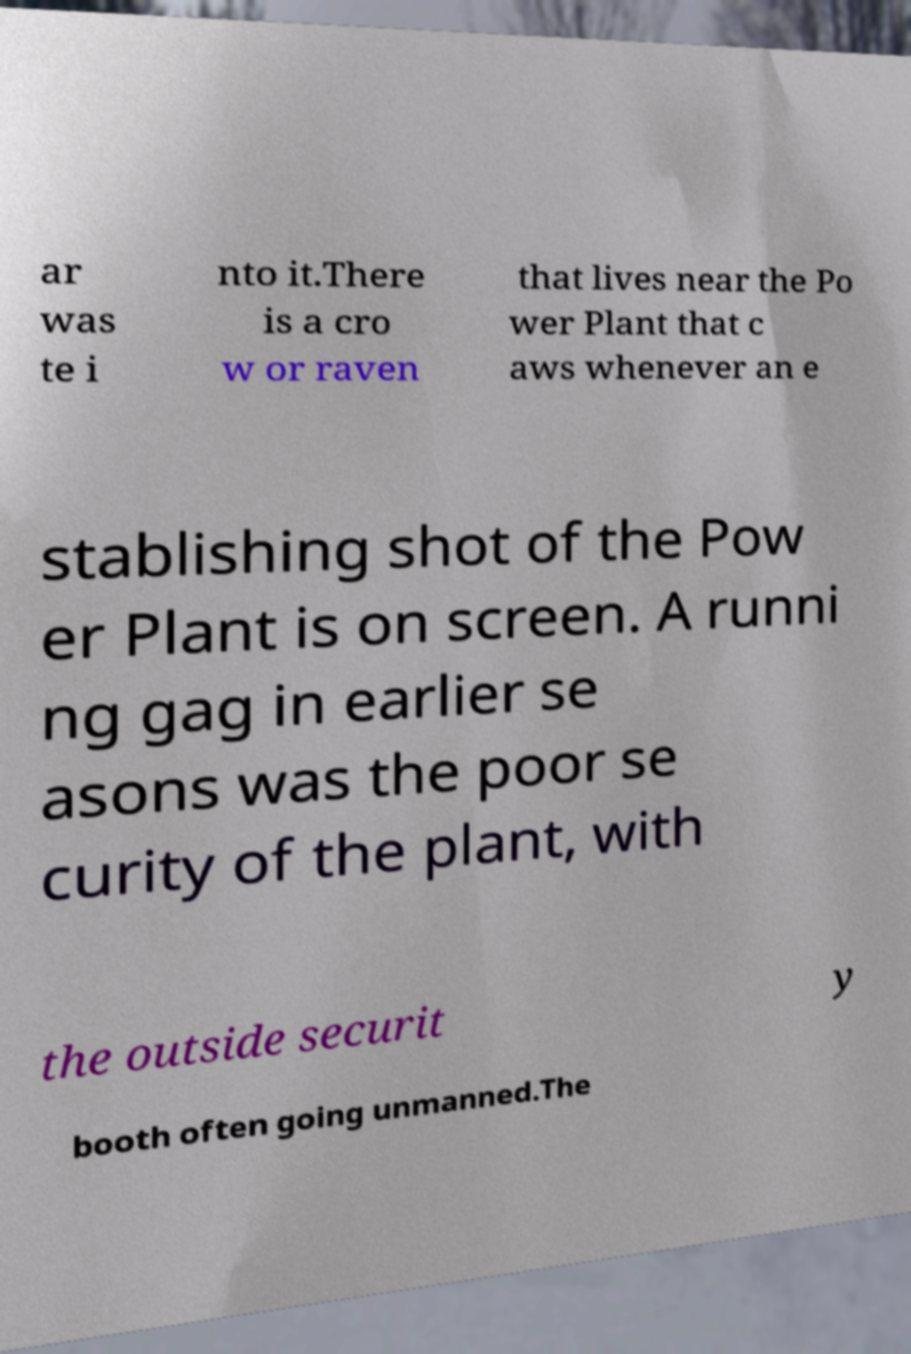Can you read and provide the text displayed in the image?This photo seems to have some interesting text. Can you extract and type it out for me? ar was te i nto it.There is a cro w or raven that lives near the Po wer Plant that c aws whenever an e stablishing shot of the Pow er Plant is on screen. A runni ng gag in earlier se asons was the poor se curity of the plant, with the outside securit y booth often going unmanned.The 